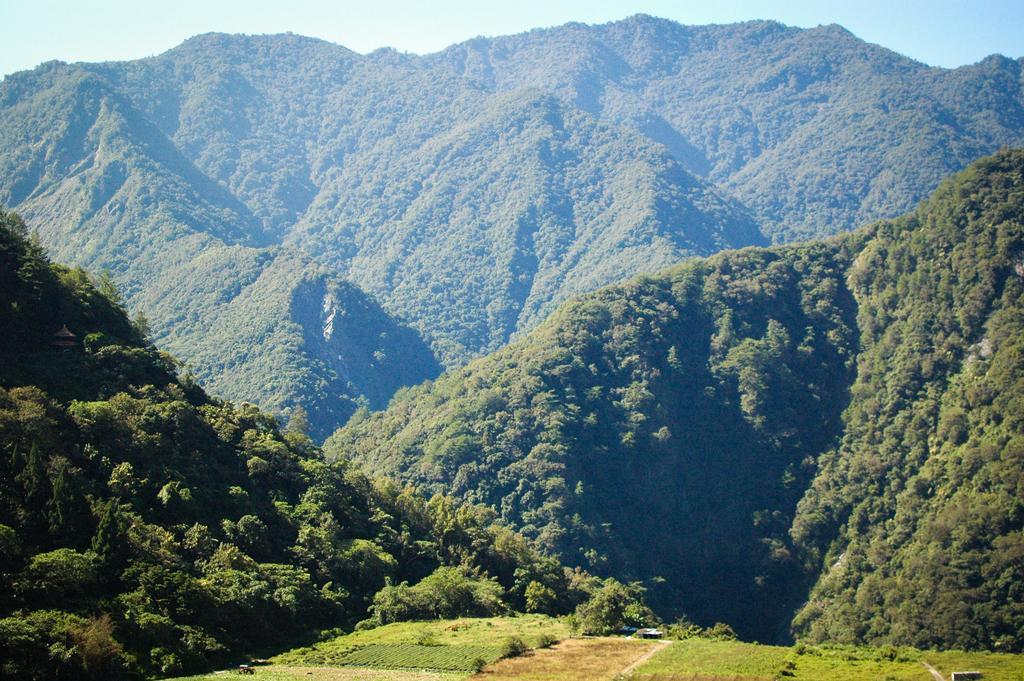Describe this image in one or two sentences. In this image there are mountains with full of trees. At the top there is sky and at the bottom grass is visible. 